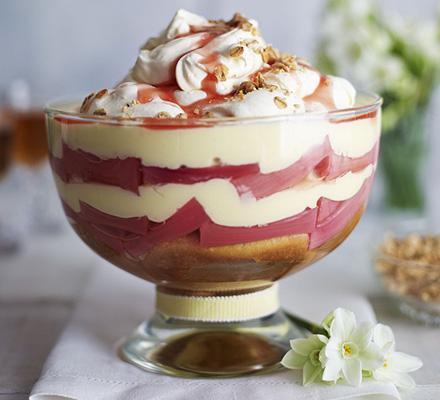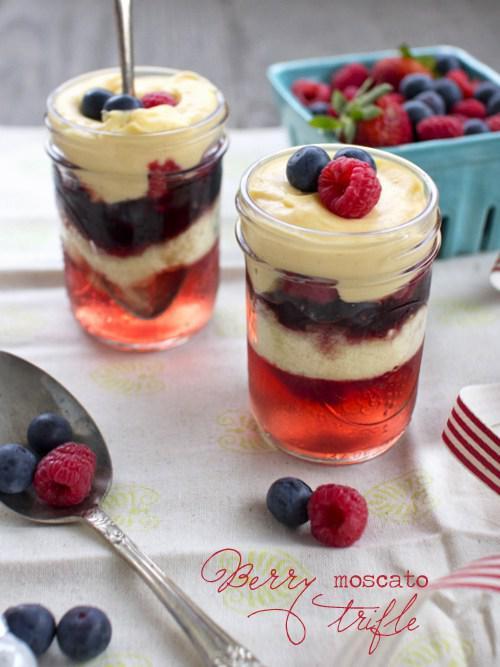The first image is the image on the left, the second image is the image on the right. For the images displayed, is the sentence "An image shows just one dessert bowl, topped with blueberries and strawberries." factually correct? Answer yes or no. No. 